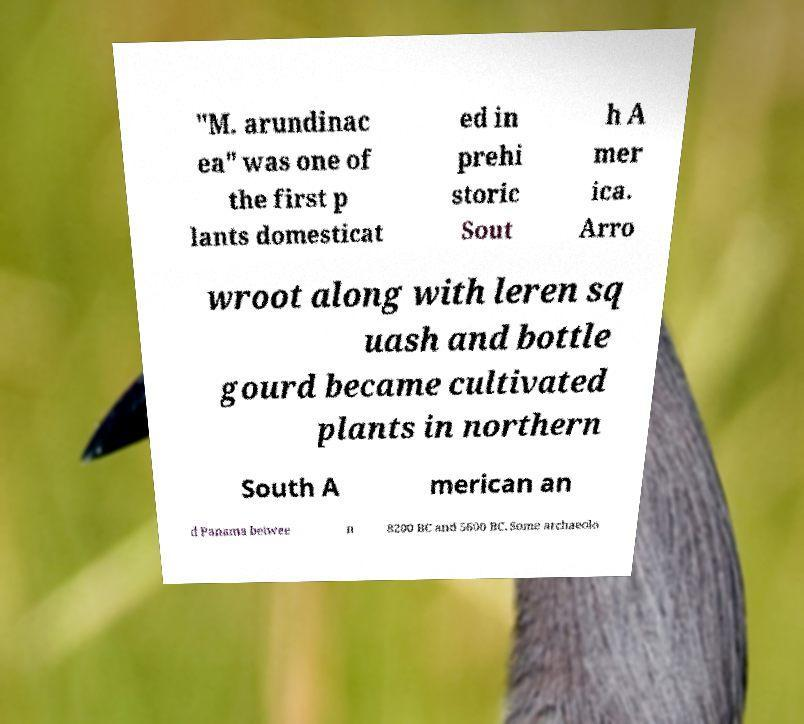For documentation purposes, I need the text within this image transcribed. Could you provide that? "M. arundinac ea" was one of the first p lants domesticat ed in prehi storic Sout h A mer ica. Arro wroot along with leren sq uash and bottle gourd became cultivated plants in northern South A merican an d Panama betwee n 8200 BC and 5600 BC. Some archaeolo 